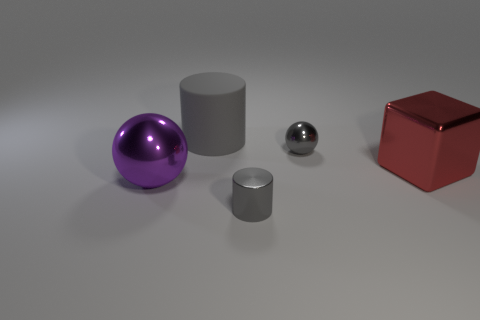Subtract all green spheres. Subtract all cyan blocks. How many spheres are left? 2 Add 4 tiny shiny cylinders. How many objects exist? 9 Subtract all spheres. How many objects are left? 3 Add 5 purple metallic spheres. How many purple metallic spheres exist? 6 Subtract 0 cyan blocks. How many objects are left? 5 Subtract all large purple rubber cylinders. Subtract all gray cylinders. How many objects are left? 3 Add 2 shiny cylinders. How many shiny cylinders are left? 3 